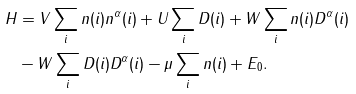Convert formula to latex. <formula><loc_0><loc_0><loc_500><loc_500>H & = V \sum _ { i } n ( i ) n ^ { \alpha } ( i ) + U \sum _ { i } D ( i ) + W \sum _ { i } n ( i ) D ^ { \alpha } ( i ) \\ & - W \sum _ { i } D ( i ) D ^ { \alpha } ( i ) - \mu \sum _ { i } n ( i ) + E _ { 0 } .</formula> 